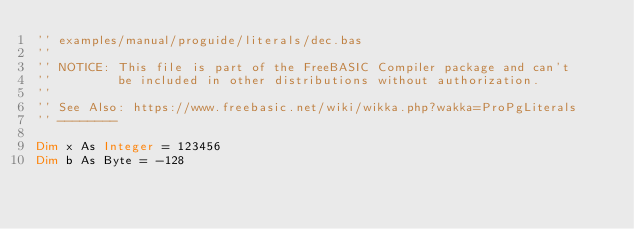<code> <loc_0><loc_0><loc_500><loc_500><_VisualBasic_>'' examples/manual/proguide/literals/dec.bas
''
'' NOTICE: This file is part of the FreeBASIC Compiler package and can't
''         be included in other distributions without authorization.
''
'' See Also: https://www.freebasic.net/wiki/wikka.php?wakka=ProPgLiterals
'' --------

Dim x As Integer = 123456
Dim b As Byte = -128
</code> 